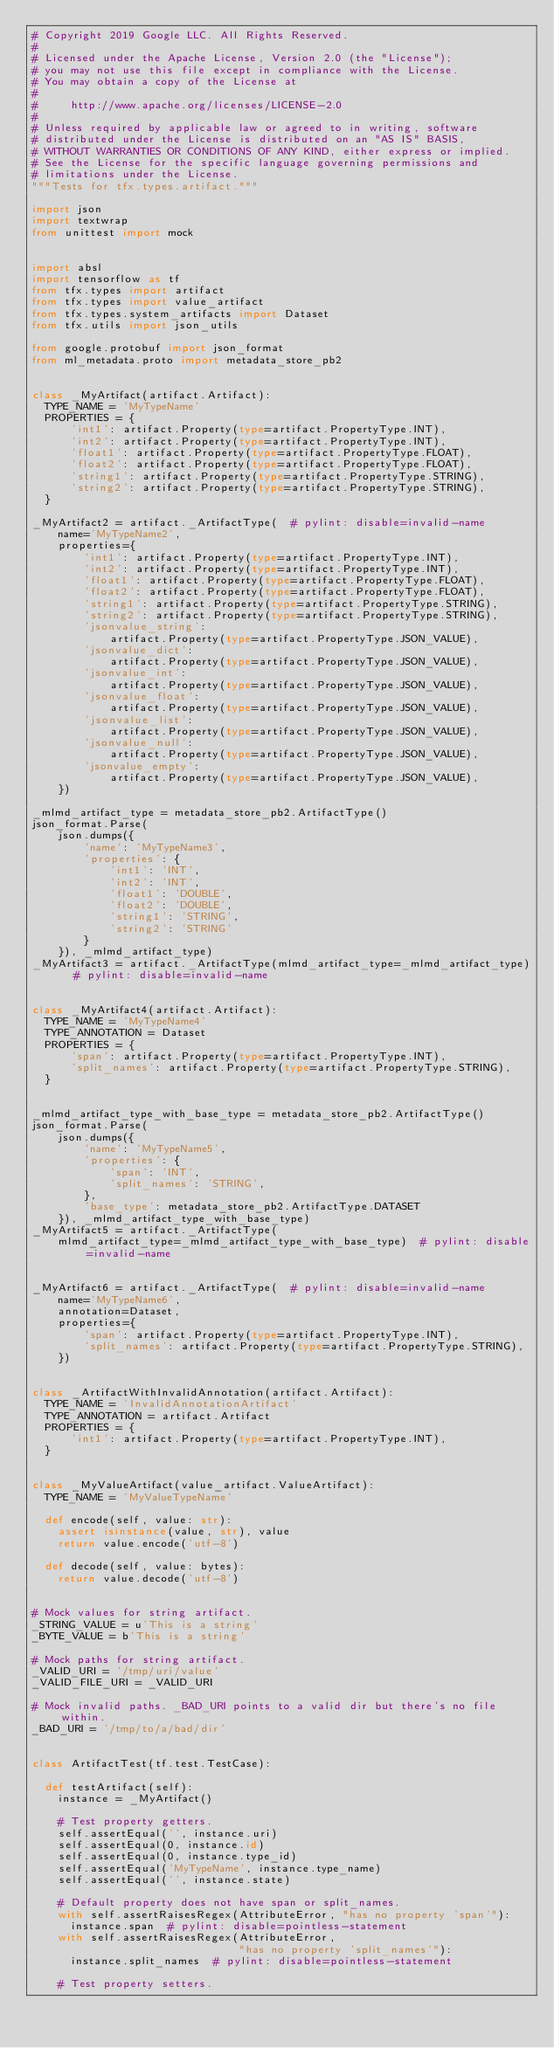Convert code to text. <code><loc_0><loc_0><loc_500><loc_500><_Python_># Copyright 2019 Google LLC. All Rights Reserved.
#
# Licensed under the Apache License, Version 2.0 (the "License");
# you may not use this file except in compliance with the License.
# You may obtain a copy of the License at
#
#     http://www.apache.org/licenses/LICENSE-2.0
#
# Unless required by applicable law or agreed to in writing, software
# distributed under the License is distributed on an "AS IS" BASIS,
# WITHOUT WARRANTIES OR CONDITIONS OF ANY KIND, either express or implied.
# See the License for the specific language governing permissions and
# limitations under the License.
"""Tests for tfx.types.artifact."""

import json
import textwrap
from unittest import mock


import absl
import tensorflow as tf
from tfx.types import artifact
from tfx.types import value_artifact
from tfx.types.system_artifacts import Dataset
from tfx.utils import json_utils

from google.protobuf import json_format
from ml_metadata.proto import metadata_store_pb2


class _MyArtifact(artifact.Artifact):
  TYPE_NAME = 'MyTypeName'
  PROPERTIES = {
      'int1': artifact.Property(type=artifact.PropertyType.INT),
      'int2': artifact.Property(type=artifact.PropertyType.INT),
      'float1': artifact.Property(type=artifact.PropertyType.FLOAT),
      'float2': artifact.Property(type=artifact.PropertyType.FLOAT),
      'string1': artifact.Property(type=artifact.PropertyType.STRING),
      'string2': artifact.Property(type=artifact.PropertyType.STRING),
  }

_MyArtifact2 = artifact._ArtifactType(  # pylint: disable=invalid-name
    name='MyTypeName2',
    properties={
        'int1': artifact.Property(type=artifact.PropertyType.INT),
        'int2': artifact.Property(type=artifact.PropertyType.INT),
        'float1': artifact.Property(type=artifact.PropertyType.FLOAT),
        'float2': artifact.Property(type=artifact.PropertyType.FLOAT),
        'string1': artifact.Property(type=artifact.PropertyType.STRING),
        'string2': artifact.Property(type=artifact.PropertyType.STRING),
        'jsonvalue_string':
            artifact.Property(type=artifact.PropertyType.JSON_VALUE),
        'jsonvalue_dict':
            artifact.Property(type=artifact.PropertyType.JSON_VALUE),
        'jsonvalue_int':
            artifact.Property(type=artifact.PropertyType.JSON_VALUE),
        'jsonvalue_float':
            artifact.Property(type=artifact.PropertyType.JSON_VALUE),
        'jsonvalue_list':
            artifact.Property(type=artifact.PropertyType.JSON_VALUE),
        'jsonvalue_null':
            artifact.Property(type=artifact.PropertyType.JSON_VALUE),
        'jsonvalue_empty':
            artifact.Property(type=artifact.PropertyType.JSON_VALUE),
    })

_mlmd_artifact_type = metadata_store_pb2.ArtifactType()
json_format.Parse(
    json.dumps({
        'name': 'MyTypeName3',
        'properties': {
            'int1': 'INT',
            'int2': 'INT',
            'float1': 'DOUBLE',
            'float2': 'DOUBLE',
            'string1': 'STRING',
            'string2': 'STRING'
        }
    }), _mlmd_artifact_type)
_MyArtifact3 = artifact._ArtifactType(mlmd_artifact_type=_mlmd_artifact_type)  # pylint: disable=invalid-name


class _MyArtifact4(artifact.Artifact):
  TYPE_NAME = 'MyTypeName4'
  TYPE_ANNOTATION = Dataset
  PROPERTIES = {
      'span': artifact.Property(type=artifact.PropertyType.INT),
      'split_names': artifact.Property(type=artifact.PropertyType.STRING),
  }


_mlmd_artifact_type_with_base_type = metadata_store_pb2.ArtifactType()
json_format.Parse(
    json.dumps({
        'name': 'MyTypeName5',
        'properties': {
            'span': 'INT',
            'split_names': 'STRING',
        },
        'base_type': metadata_store_pb2.ArtifactType.DATASET
    }), _mlmd_artifact_type_with_base_type)
_MyArtifact5 = artifact._ArtifactType(
    mlmd_artifact_type=_mlmd_artifact_type_with_base_type)  # pylint: disable=invalid-name


_MyArtifact6 = artifact._ArtifactType(  # pylint: disable=invalid-name
    name='MyTypeName6',
    annotation=Dataset,
    properties={
        'span': artifact.Property(type=artifact.PropertyType.INT),
        'split_names': artifact.Property(type=artifact.PropertyType.STRING),
    })


class _ArtifactWithInvalidAnnotation(artifact.Artifact):
  TYPE_NAME = 'InvalidAnnotationArtifact'
  TYPE_ANNOTATION = artifact.Artifact
  PROPERTIES = {
      'int1': artifact.Property(type=artifact.PropertyType.INT),
  }


class _MyValueArtifact(value_artifact.ValueArtifact):
  TYPE_NAME = 'MyValueTypeName'

  def encode(self, value: str):
    assert isinstance(value, str), value
    return value.encode('utf-8')

  def decode(self, value: bytes):
    return value.decode('utf-8')


# Mock values for string artifact.
_STRING_VALUE = u'This is a string'
_BYTE_VALUE = b'This is a string'

# Mock paths for string artifact.
_VALID_URI = '/tmp/uri/value'
_VALID_FILE_URI = _VALID_URI

# Mock invalid paths. _BAD_URI points to a valid dir but there's no file within.
_BAD_URI = '/tmp/to/a/bad/dir'


class ArtifactTest(tf.test.TestCase):

  def testArtifact(self):
    instance = _MyArtifact()

    # Test property getters.
    self.assertEqual('', instance.uri)
    self.assertEqual(0, instance.id)
    self.assertEqual(0, instance.type_id)
    self.assertEqual('MyTypeName', instance.type_name)
    self.assertEqual('', instance.state)

    # Default property does not have span or split_names.
    with self.assertRaisesRegex(AttributeError, "has no property 'span'"):
      instance.span  # pylint: disable=pointless-statement
    with self.assertRaisesRegex(AttributeError,
                                "has no property 'split_names'"):
      instance.split_names  # pylint: disable=pointless-statement

    # Test property setters.</code> 